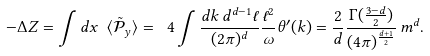<formula> <loc_0><loc_0><loc_500><loc_500>- \Delta Z = \int d x \ \langle \tilde { \mathcal { P } } _ { y } \rangle = \ 4 \int \frac { d k \, d ^ { d - 1 } \ell } { ( 2 \pi ) ^ { d } } \frac { \ell ^ { 2 } } { \omega } \theta ^ { \prime } ( k ) = \frac { 2 } { d } \frac { \Gamma ( \frac { 3 - d } { 2 } ) } { ( 4 \pi ) ^ { \frac { d + 1 } { 2 } } } \, m ^ { d } .</formula> 